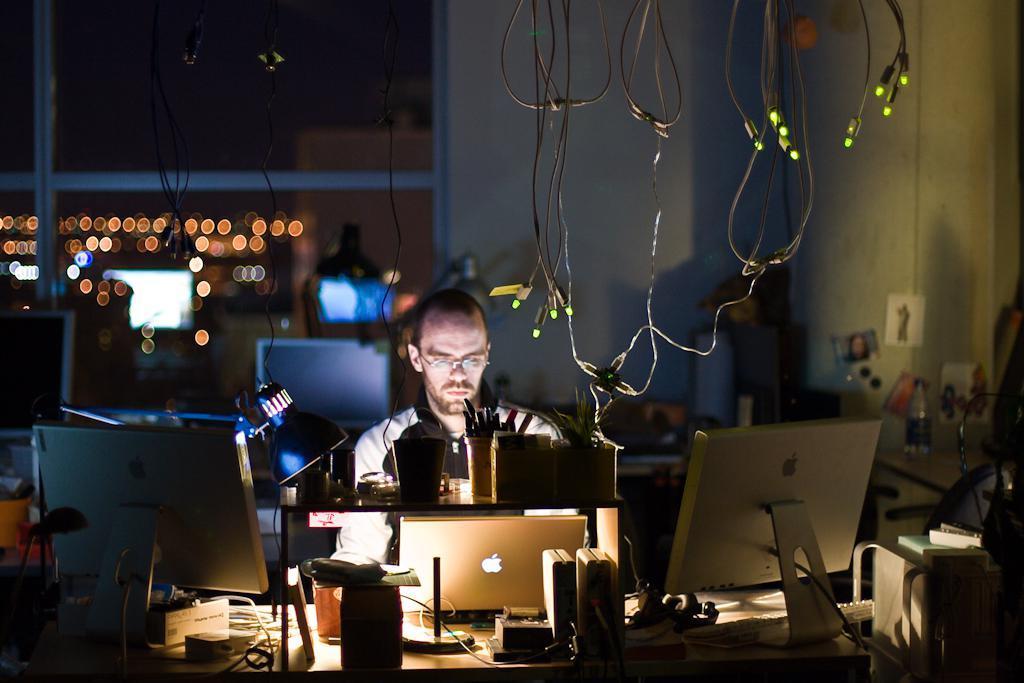Please provide a concise description of this image. Here on the table we can see two monitors,cables,lamp,laptop,pens in a cup,small house plants in small pots and some other objects. We can see a man here. In the background we can see lights,glass doors,wall,poster on the wall,cables with lights and on the glass door we can see the reflections of screens and lights and there are some other objects over here. 